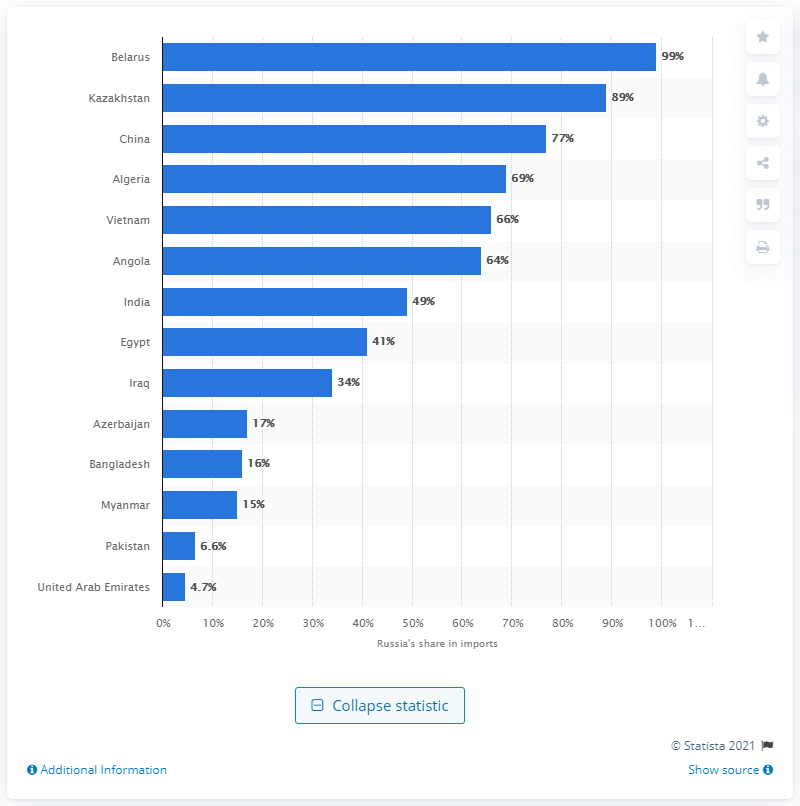List a handful of essential elements in this visual. According to information, Russia accounted for approximately 99% of Belarus's total weapons imports in a particular year. 